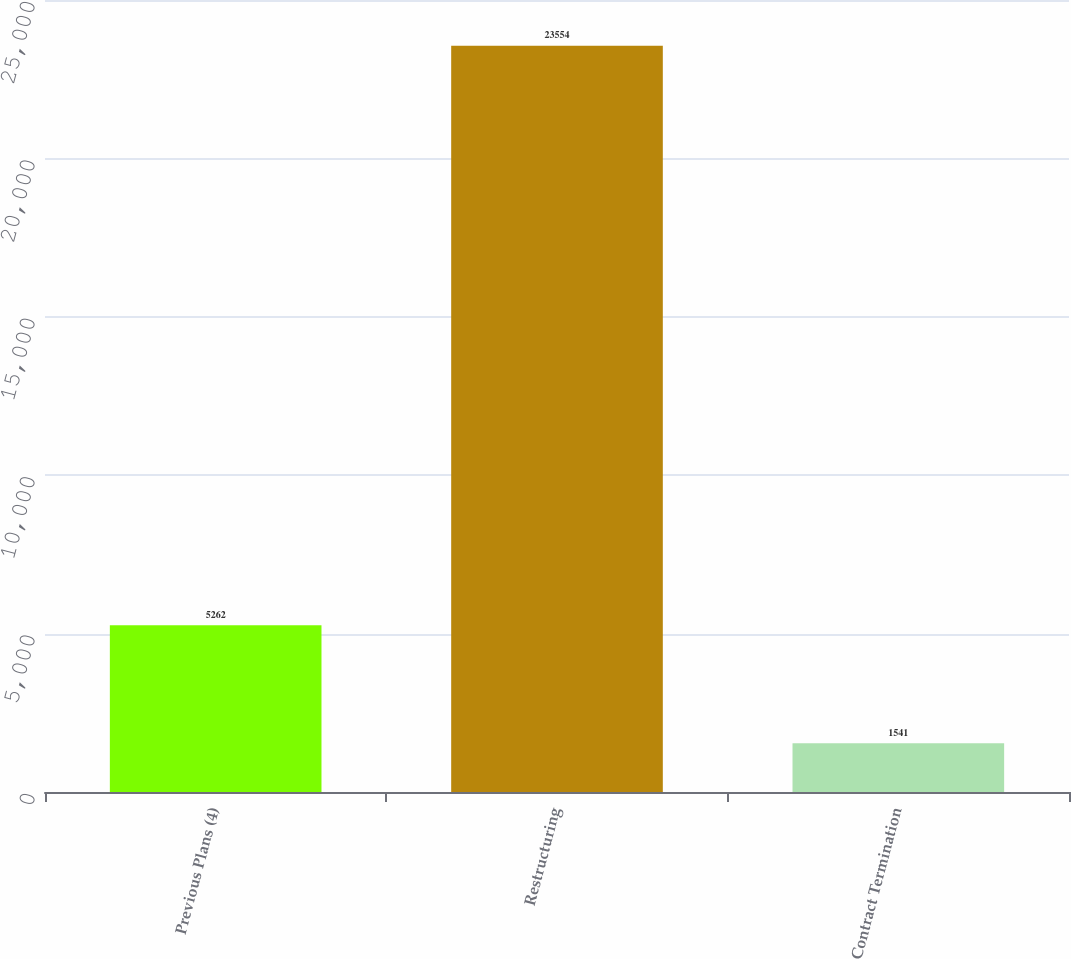Convert chart to OTSL. <chart><loc_0><loc_0><loc_500><loc_500><bar_chart><fcel>Previous Plans (4)<fcel>Restructuring<fcel>Contract Termination<nl><fcel>5262<fcel>23554<fcel>1541<nl></chart> 